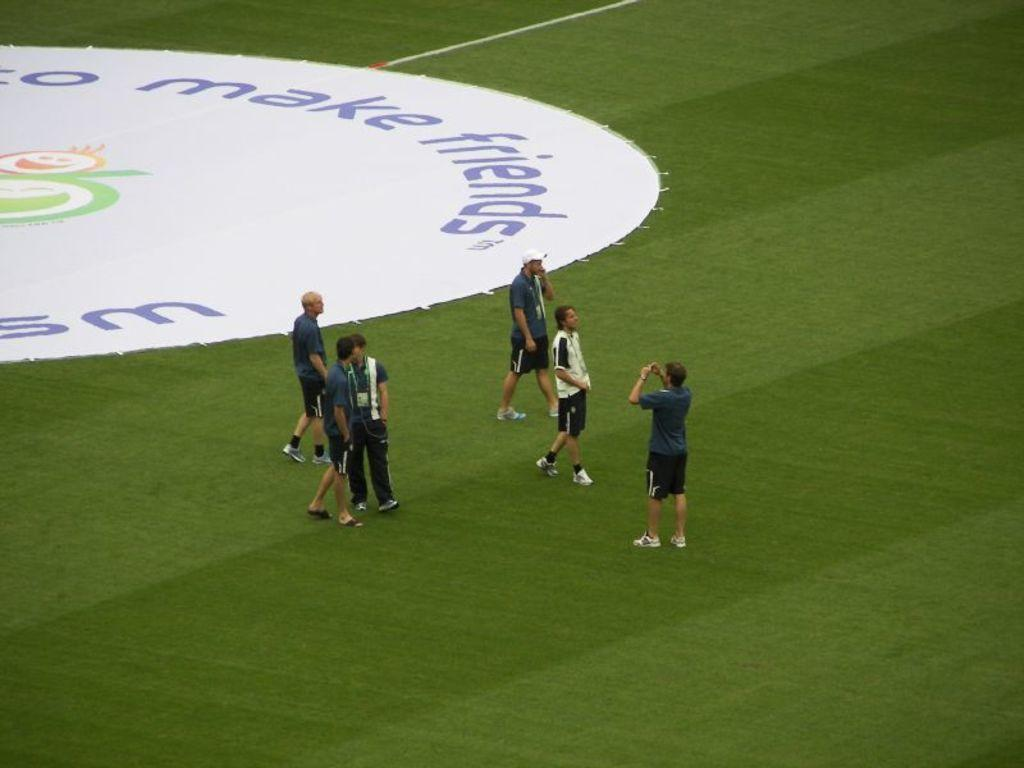<image>
Present a compact description of the photo's key features. A soccer field has a large pad on it that says to Make Friends. 